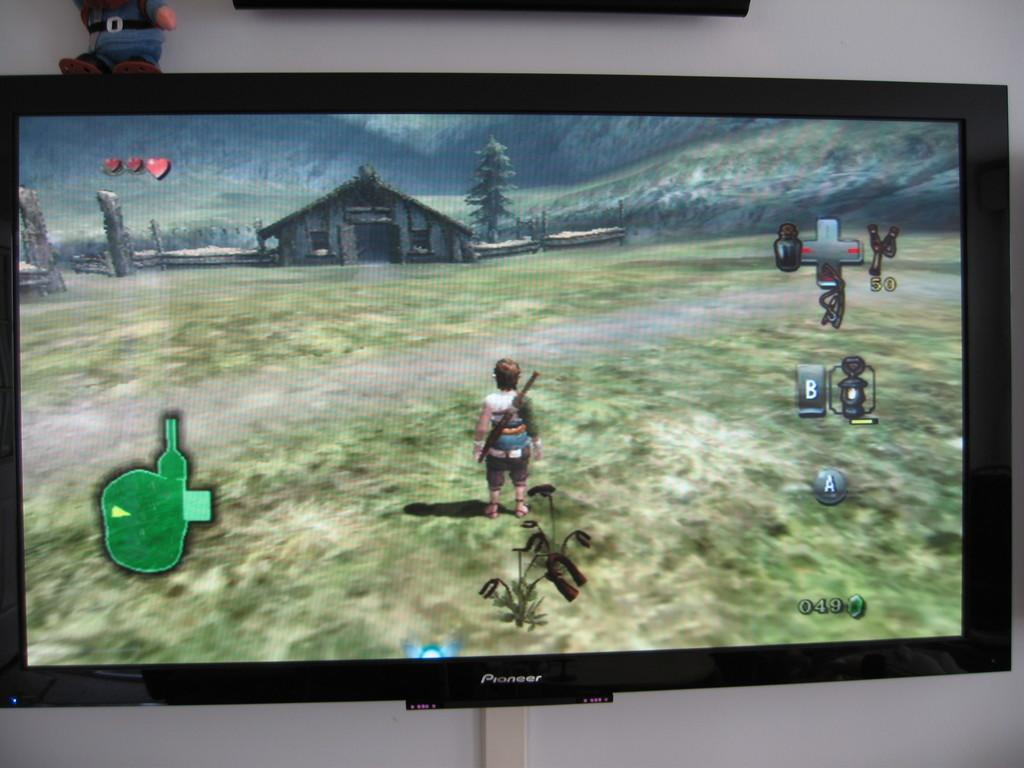What is the main object in the middle of the picture? There is a television in the picture, and it is in the middle of the picture. What is being displayed on the television screen? A video game is visible on the television screen. How many mice are visible in the picture? There are no mice present in the image. What type of mine is being used to extract resources in the image? There is no mine or any reference to a mine in the image. 